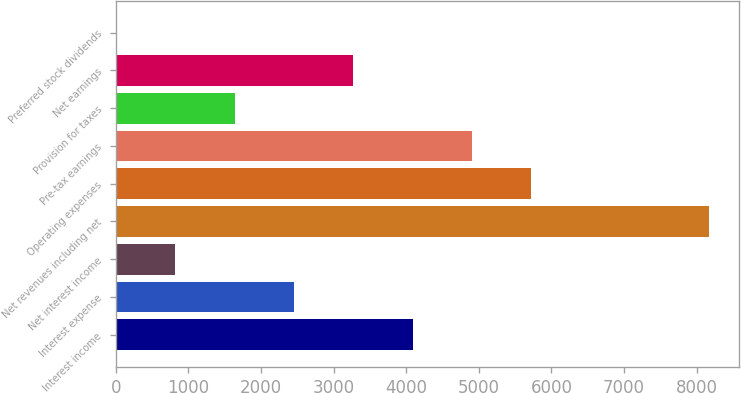Convert chart. <chart><loc_0><loc_0><loc_500><loc_500><bar_chart><fcel>Interest income<fcel>Interest expense<fcel>Net interest income<fcel>Net revenues including net<fcel>Operating expenses<fcel>Pre-tax earnings<fcel>Provision for taxes<fcel>Net earnings<fcel>Preferred stock dividends<nl><fcel>4087<fcel>2454.6<fcel>822.2<fcel>8168<fcel>5719.4<fcel>4903.2<fcel>1638.4<fcel>3270.8<fcel>6<nl></chart> 